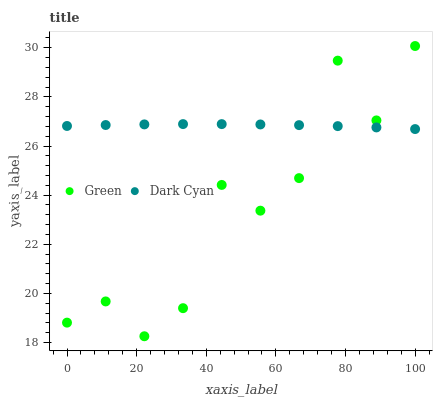Does Green have the minimum area under the curve?
Answer yes or no. Yes. Does Dark Cyan have the maximum area under the curve?
Answer yes or no. Yes. Does Green have the maximum area under the curve?
Answer yes or no. No. Is Dark Cyan the smoothest?
Answer yes or no. Yes. Is Green the roughest?
Answer yes or no. Yes. Is Green the smoothest?
Answer yes or no. No. Does Green have the lowest value?
Answer yes or no. Yes. Does Green have the highest value?
Answer yes or no. Yes. Does Green intersect Dark Cyan?
Answer yes or no. Yes. Is Green less than Dark Cyan?
Answer yes or no. No. Is Green greater than Dark Cyan?
Answer yes or no. No. 